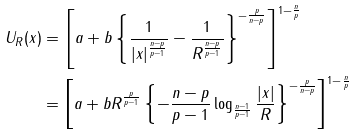Convert formula to latex. <formula><loc_0><loc_0><loc_500><loc_500>U _ { R } ( x ) & = \left [ a + b \left \{ \frac { 1 } { | x | ^ { \frac { n - p } { p - 1 } } } - \frac { 1 } { R ^ { \frac { n - p } { p - 1 } } } \right \} ^ { - \frac { p } { n - p } } \right ] ^ { 1 - \frac { n } { p } } \\ & = \left [ a + b R ^ { \frac { p } { p - 1 } } \left \{ - \frac { n - p } { p - 1 } \log _ { \frac { n - 1 } { p - 1 } } \frac { | x | } { R } \right \} ^ { - \frac { p } { n - p } } \right ] ^ { 1 - \frac { n } { p } }</formula> 